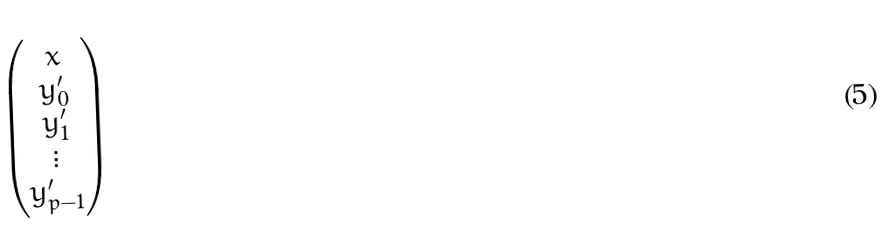<formula> <loc_0><loc_0><loc_500><loc_500>\begin{pmatrix} x \\ y _ { 0 } ^ { \prime } \\ y _ { 1 } ^ { \prime } \\ \vdots \\ y _ { p - 1 } ^ { \prime } \end{pmatrix}</formula> 